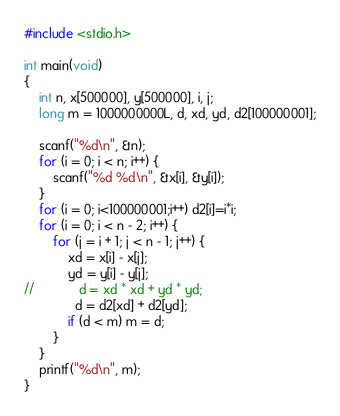Convert code to text. <code><loc_0><loc_0><loc_500><loc_500><_C_>#include <stdio.h>

int main(void)
{
    int n, x[500000], y[500000], i, j;
    long m = 1000000000L, d, xd, yd, d2[100000001];

    scanf("%d\n", &n);
    for (i = 0; i < n; i++) {
        scanf("%d %d\n", &x[i], &y[i]);
    }
    for (i = 0; i<100000001;i++) d2[i]=i*i;
    for (i = 0; i < n - 2; i++) {
        for (j = i + 1; j < n - 1; j++) {
            xd = x[i] - x[j];
            yd = y[i] - y[j];
//            d = xd * xd + yd * yd;
              d = d2[xd] + d2[yd];
            if (d < m) m = d;
        }
    }
    printf("%d\n", m);
}

</code> 